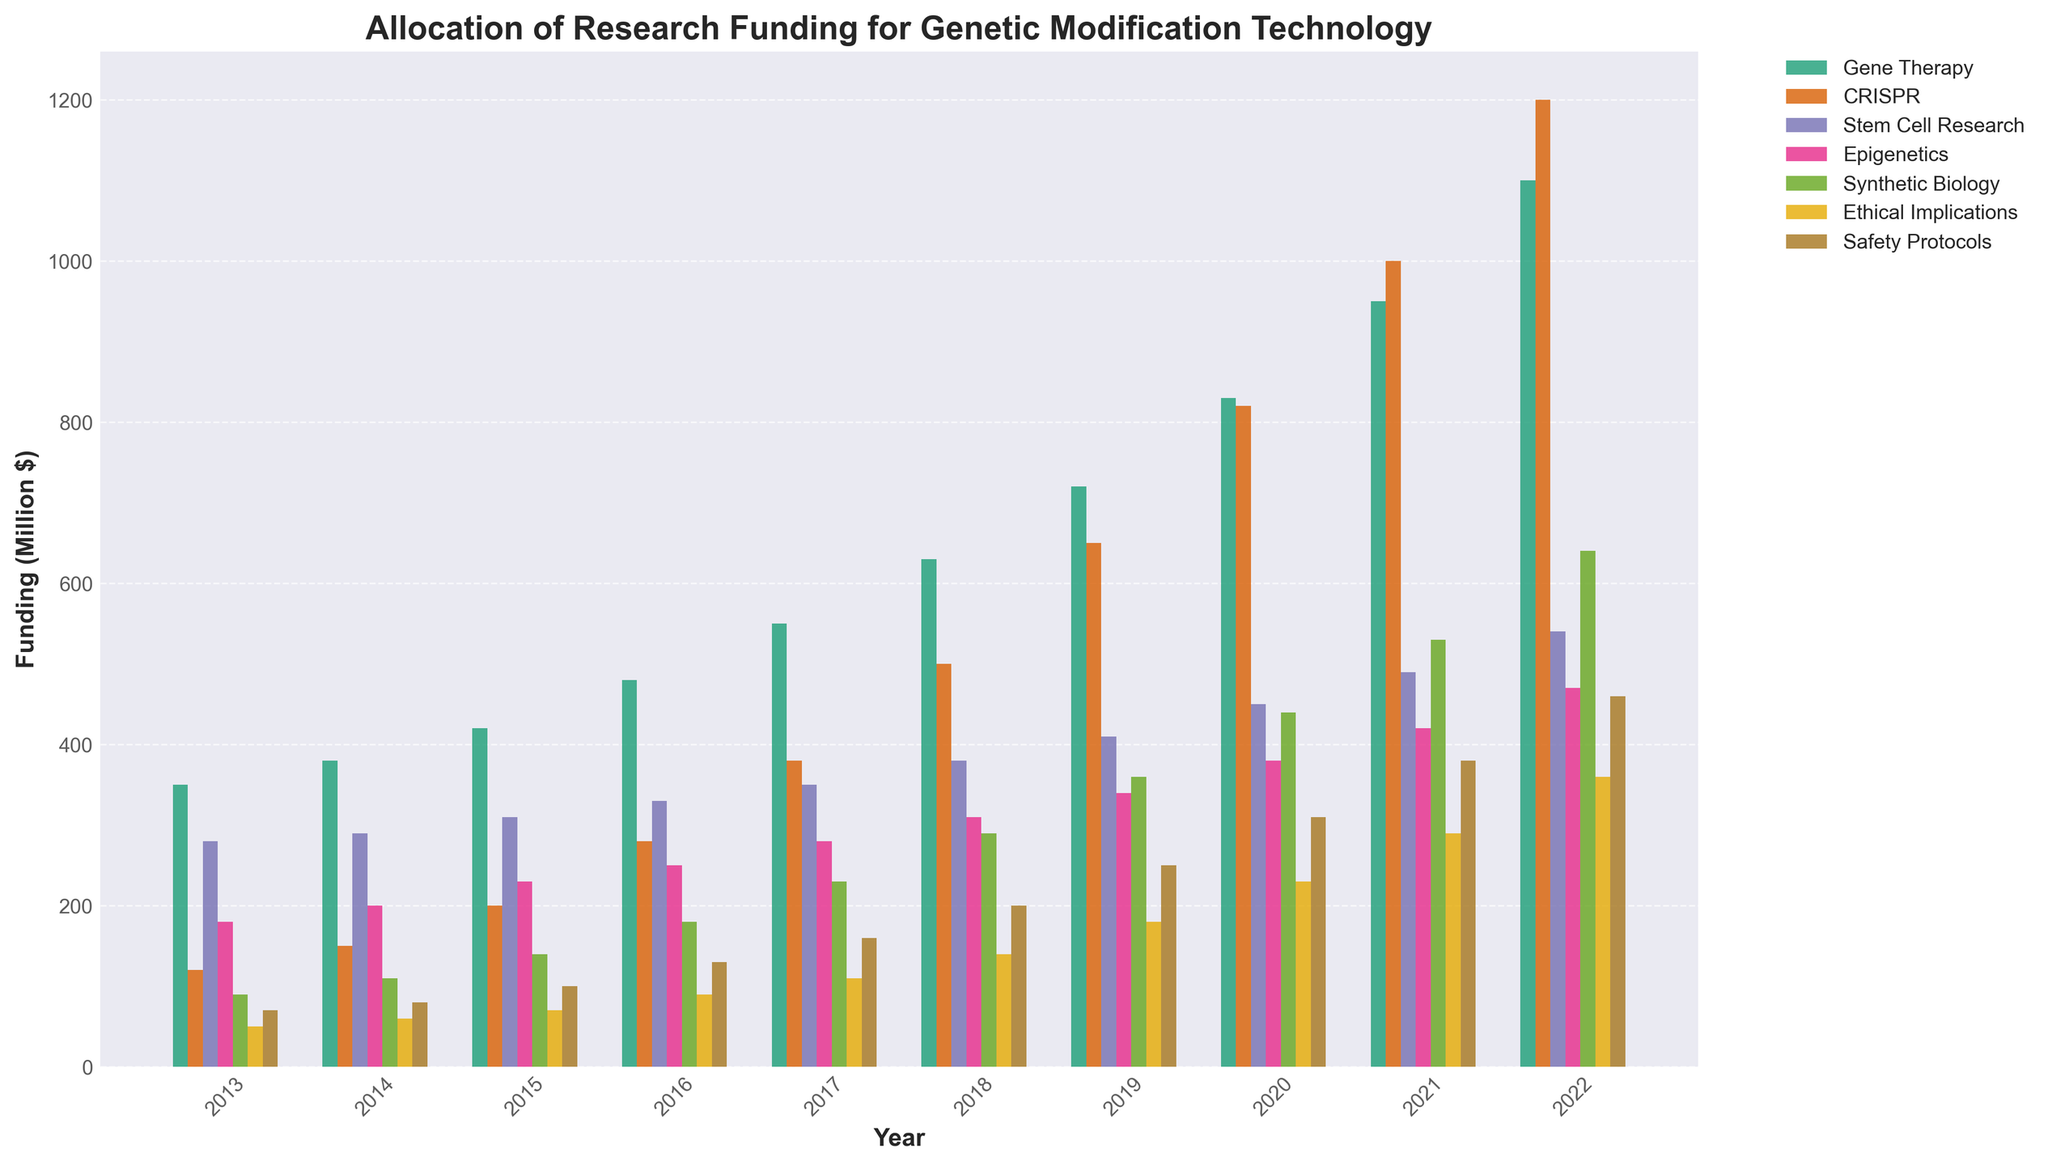What year had the highest funding for Gene Therapy? Look at the bars representing Gene Therapy and identify the tallest one. The highest bar is in 2022.
Answer: 2022 How did the funding for CRISPR change from 2013 to 2022? Compare the height of the CRISPR bars in 2013 and 2022. In 2013, the funding was 120, and in 2022, it was 1200. The funding increased by 1080.
Answer: Increased by 1080 Which category saw the smallest increase in funding from 2013 to 2022? Calculate the difference between the funding in 2022 and 2013 for each category, and identify the smallest difference. The smallest increase is for Ethical Implications, from 50 to 360, an increase of 310.
Answer: Ethical Implications How does the funding for Synthetic Biology in 2018 compare to Safety Protocols in 2018? Compare the heights of the bars for Synthetic Biology and Safety Protocols in 2018. Funding for Synthetic Biology is 290 and for Safety Protocols is 200. Synthetic Biology has higher funding.
Answer: Synthetic Biology has higher funding What is the average funding for Epigenetics over the given years? Sum the values for Epigenetics from 2013 to 2022 and divide by the number of years. Sum is 180+200+230+250+280+310+340+380+420+470 = 3060. Average is 3060 / 10 = 306.
Answer: 306 Compare the funding for Gene Therapy and CRISPR in 2021. Which one is higher and by how much? Compare the heights of the Gene Therapy and CRISPR bars in 2021. Gene Therapy is 950, and CRISPR is 1000. Difference is 1000 - 950 = 50.
Answer: CRISPR is higher by 50 What is the trend in funding for Stem Cell Research from 2013 to 2022? Observe the trend in the heights of the bars for Stem Cell Research from 2013 to 2022. The bars increase gradually each year.
Answer: Increasing trend How much total funding was allocated for Ethical Implications between 2013 and 2017? Sum the values for Ethical Implications from 2013 to 2017. Sum is 50 + 60 + 70 + 90 + 110 = 380.
Answer: 380 Describe the visual difference between the funding for Safety Protocols and Epigenetics in 2015. Compare the heights and colors of the bars for Safety Protocols and Epigenetics in 2015. Safety Protocols is shorter and likely lighter in color compared to Epigenetics.
Answer: Safety Protocols is shorter Which category had the highest increase in funding from 2013 to 2022? Calculate the difference in funding between 2013 and 2022 for each category, and identify the largest difference. CRISPR went from 120 to 1200, an increase of 1080.
Answer: CRISPR 